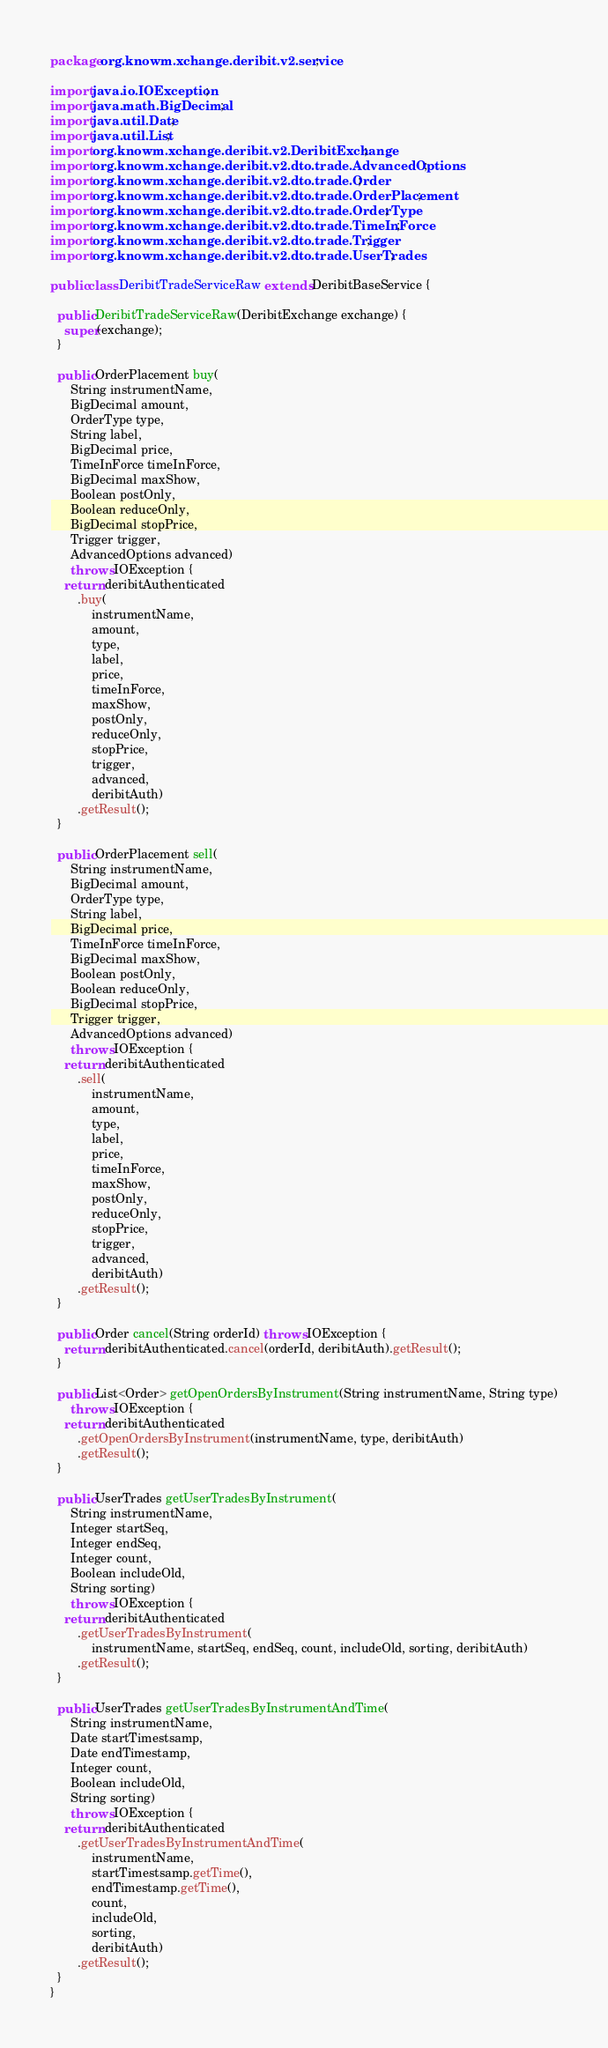Convert code to text. <code><loc_0><loc_0><loc_500><loc_500><_Java_>package org.knowm.xchange.deribit.v2.service;

import java.io.IOException;
import java.math.BigDecimal;
import java.util.Date;
import java.util.List;
import org.knowm.xchange.deribit.v2.DeribitExchange;
import org.knowm.xchange.deribit.v2.dto.trade.AdvancedOptions;
import org.knowm.xchange.deribit.v2.dto.trade.Order;
import org.knowm.xchange.deribit.v2.dto.trade.OrderPlacement;
import org.knowm.xchange.deribit.v2.dto.trade.OrderType;
import org.knowm.xchange.deribit.v2.dto.trade.TimeInForce;
import org.knowm.xchange.deribit.v2.dto.trade.Trigger;
import org.knowm.xchange.deribit.v2.dto.trade.UserTrades;

public class DeribitTradeServiceRaw extends DeribitBaseService {

  public DeribitTradeServiceRaw(DeribitExchange exchange) {
    super(exchange);
  }

  public OrderPlacement buy(
      String instrumentName,
      BigDecimal amount,
      OrderType type,
      String label,
      BigDecimal price,
      TimeInForce timeInForce,
      BigDecimal maxShow,
      Boolean postOnly,
      Boolean reduceOnly,
      BigDecimal stopPrice,
      Trigger trigger,
      AdvancedOptions advanced)
      throws IOException {
    return deribitAuthenticated
        .buy(
            instrumentName,
            amount,
            type,
            label,
            price,
            timeInForce,
            maxShow,
            postOnly,
            reduceOnly,
            stopPrice,
            trigger,
            advanced,
            deribitAuth)
        .getResult();
  }

  public OrderPlacement sell(
      String instrumentName,
      BigDecimal amount,
      OrderType type,
      String label,
      BigDecimal price,
      TimeInForce timeInForce,
      BigDecimal maxShow,
      Boolean postOnly,
      Boolean reduceOnly,
      BigDecimal stopPrice,
      Trigger trigger,
      AdvancedOptions advanced)
      throws IOException {
    return deribitAuthenticated
        .sell(
            instrumentName,
            amount,
            type,
            label,
            price,
            timeInForce,
            maxShow,
            postOnly,
            reduceOnly,
            stopPrice,
            trigger,
            advanced,
            deribitAuth)
        .getResult();
  }

  public Order cancel(String orderId) throws IOException {
    return deribitAuthenticated.cancel(orderId, deribitAuth).getResult();
  }

  public List<Order> getOpenOrdersByInstrument(String instrumentName, String type)
      throws IOException {
    return deribitAuthenticated
        .getOpenOrdersByInstrument(instrumentName, type, deribitAuth)
        .getResult();
  }

  public UserTrades getUserTradesByInstrument(
      String instrumentName,
      Integer startSeq,
      Integer endSeq,
      Integer count,
      Boolean includeOld,
      String sorting)
      throws IOException {
    return deribitAuthenticated
        .getUserTradesByInstrument(
            instrumentName, startSeq, endSeq, count, includeOld, sorting, deribitAuth)
        .getResult();
  }

  public UserTrades getUserTradesByInstrumentAndTime(
      String instrumentName,
      Date startTimestsamp,
      Date endTimestamp,
      Integer count,
      Boolean includeOld,
      String sorting)
      throws IOException {
    return deribitAuthenticated
        .getUserTradesByInstrumentAndTime(
            instrumentName,
            startTimestsamp.getTime(),
            endTimestamp.getTime(),
            count,
            includeOld,
            sorting,
            deribitAuth)
        .getResult();
  }
}
</code> 